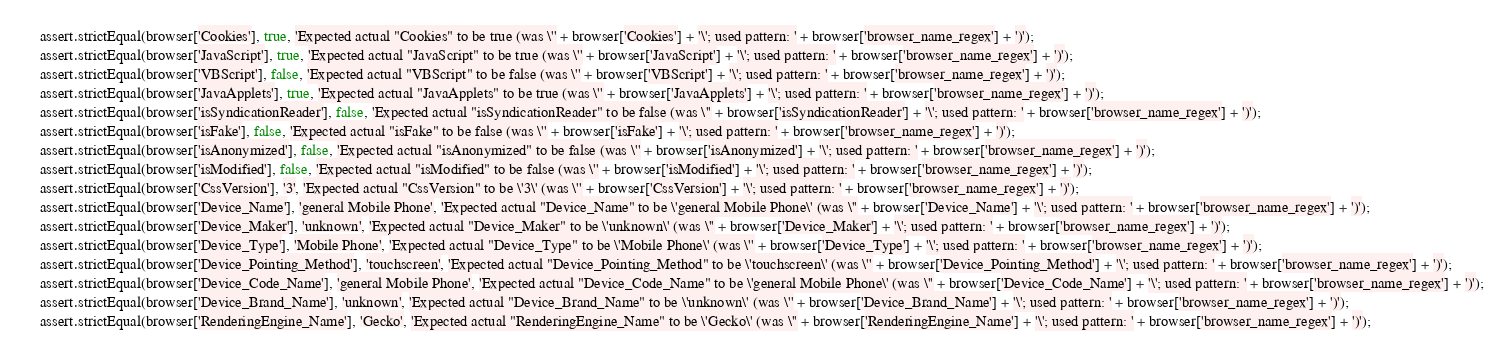<code> <loc_0><loc_0><loc_500><loc_500><_JavaScript_>    assert.strictEqual(browser['Cookies'], true, 'Expected actual "Cookies" to be true (was \'' + browser['Cookies'] + '\'; used pattern: ' + browser['browser_name_regex'] + ')');
    assert.strictEqual(browser['JavaScript'], true, 'Expected actual "JavaScript" to be true (was \'' + browser['JavaScript'] + '\'; used pattern: ' + browser['browser_name_regex'] + ')');
    assert.strictEqual(browser['VBScript'], false, 'Expected actual "VBScript" to be false (was \'' + browser['VBScript'] + '\'; used pattern: ' + browser['browser_name_regex'] + ')');
    assert.strictEqual(browser['JavaApplets'], true, 'Expected actual "JavaApplets" to be true (was \'' + browser['JavaApplets'] + '\'; used pattern: ' + browser['browser_name_regex'] + ')');
    assert.strictEqual(browser['isSyndicationReader'], false, 'Expected actual "isSyndicationReader" to be false (was \'' + browser['isSyndicationReader'] + '\'; used pattern: ' + browser['browser_name_regex'] + ')');
    assert.strictEqual(browser['isFake'], false, 'Expected actual "isFake" to be false (was \'' + browser['isFake'] + '\'; used pattern: ' + browser['browser_name_regex'] + ')');
    assert.strictEqual(browser['isAnonymized'], false, 'Expected actual "isAnonymized" to be false (was \'' + browser['isAnonymized'] + '\'; used pattern: ' + browser['browser_name_regex'] + ')');
    assert.strictEqual(browser['isModified'], false, 'Expected actual "isModified" to be false (was \'' + browser['isModified'] + '\'; used pattern: ' + browser['browser_name_regex'] + ')');
    assert.strictEqual(browser['CssVersion'], '3', 'Expected actual "CssVersion" to be \'3\' (was \'' + browser['CssVersion'] + '\'; used pattern: ' + browser['browser_name_regex'] + ')');
    assert.strictEqual(browser['Device_Name'], 'general Mobile Phone', 'Expected actual "Device_Name" to be \'general Mobile Phone\' (was \'' + browser['Device_Name'] + '\'; used pattern: ' + browser['browser_name_regex'] + ')');
    assert.strictEqual(browser['Device_Maker'], 'unknown', 'Expected actual "Device_Maker" to be \'unknown\' (was \'' + browser['Device_Maker'] + '\'; used pattern: ' + browser['browser_name_regex'] + ')');
    assert.strictEqual(browser['Device_Type'], 'Mobile Phone', 'Expected actual "Device_Type" to be \'Mobile Phone\' (was \'' + browser['Device_Type'] + '\'; used pattern: ' + browser['browser_name_regex'] + ')');
    assert.strictEqual(browser['Device_Pointing_Method'], 'touchscreen', 'Expected actual "Device_Pointing_Method" to be \'touchscreen\' (was \'' + browser['Device_Pointing_Method'] + '\'; used pattern: ' + browser['browser_name_regex'] + ')');
    assert.strictEqual(browser['Device_Code_Name'], 'general Mobile Phone', 'Expected actual "Device_Code_Name" to be \'general Mobile Phone\' (was \'' + browser['Device_Code_Name'] + '\'; used pattern: ' + browser['browser_name_regex'] + ')');
    assert.strictEqual(browser['Device_Brand_Name'], 'unknown', 'Expected actual "Device_Brand_Name" to be \'unknown\' (was \'' + browser['Device_Brand_Name'] + '\'; used pattern: ' + browser['browser_name_regex'] + ')');
    assert.strictEqual(browser['RenderingEngine_Name'], 'Gecko', 'Expected actual "RenderingEngine_Name" to be \'Gecko\' (was \'' + browser['RenderingEngine_Name'] + '\'; used pattern: ' + browser['browser_name_regex'] + ')');</code> 